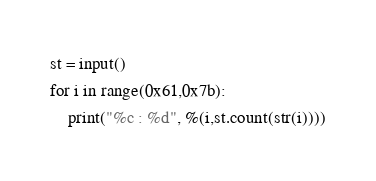<code> <loc_0><loc_0><loc_500><loc_500><_Python_>st = input()
for i in range(0x61,0x7b):
    print("%c : %d", %(i,st.count(str(i))))
</code> 